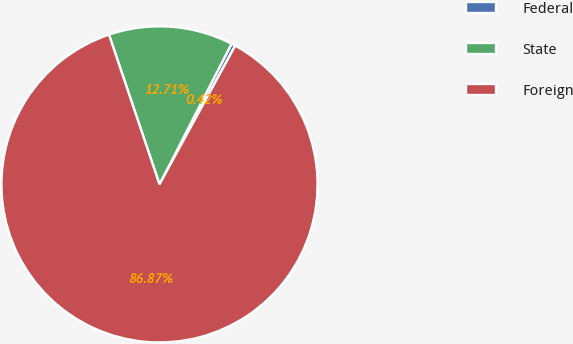<chart> <loc_0><loc_0><loc_500><loc_500><pie_chart><fcel>Federal<fcel>State<fcel>Foreign<nl><fcel>0.42%<fcel>12.71%<fcel>86.86%<nl></chart> 